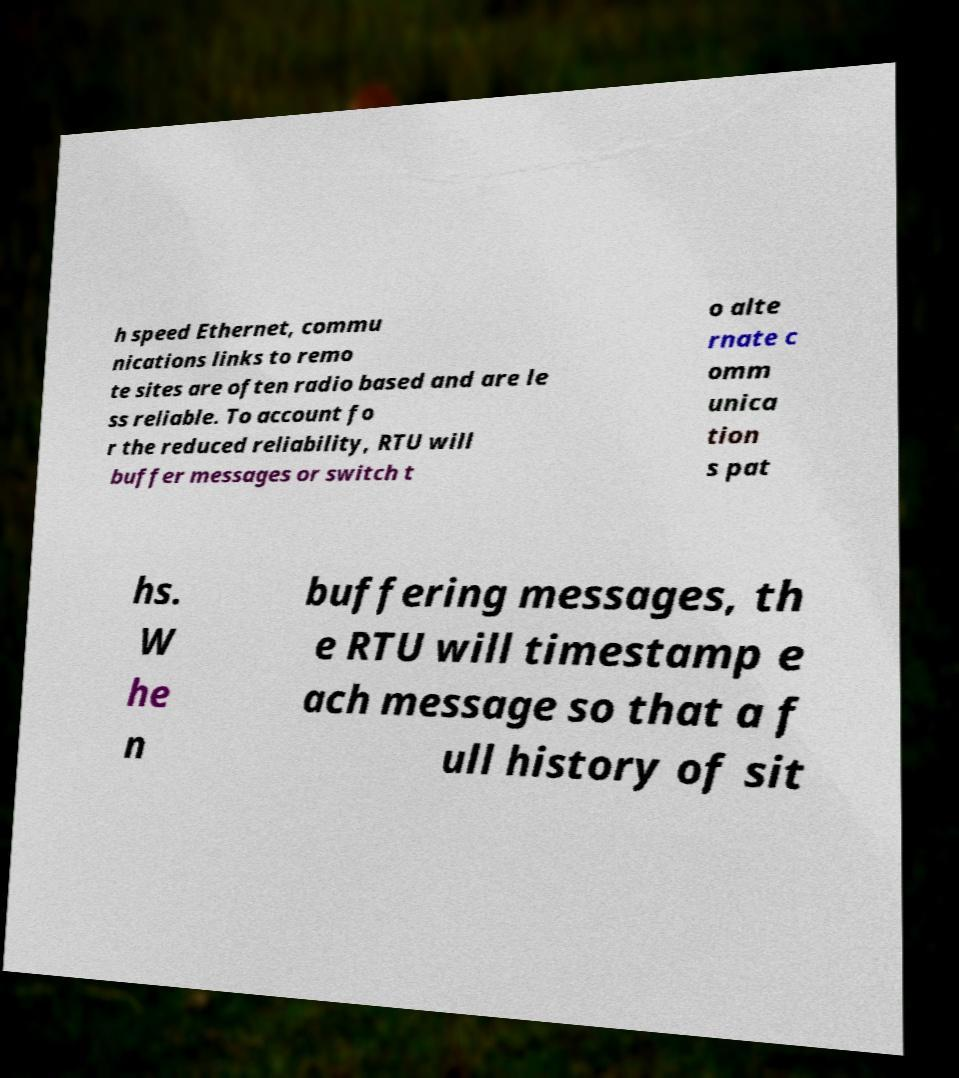Please identify and transcribe the text found in this image. h speed Ethernet, commu nications links to remo te sites are often radio based and are le ss reliable. To account fo r the reduced reliability, RTU will buffer messages or switch t o alte rnate c omm unica tion s pat hs. W he n buffering messages, th e RTU will timestamp e ach message so that a f ull history of sit 